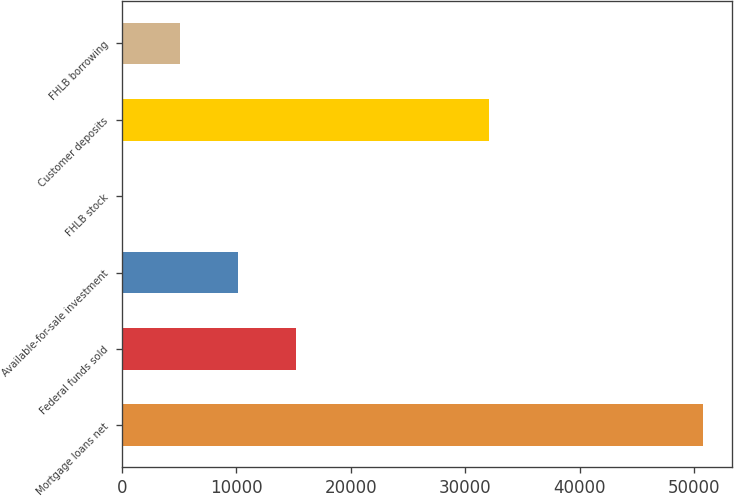Convert chart. <chart><loc_0><loc_0><loc_500><loc_500><bar_chart><fcel>Mortgage loans net<fcel>Federal funds sold<fcel>Available-for-sale investment<fcel>FHLB stock<fcel>Customer deposits<fcel>FHLB borrowing<nl><fcel>50767<fcel>15246.9<fcel>10172.6<fcel>24<fcel>32128<fcel>5098.3<nl></chart> 